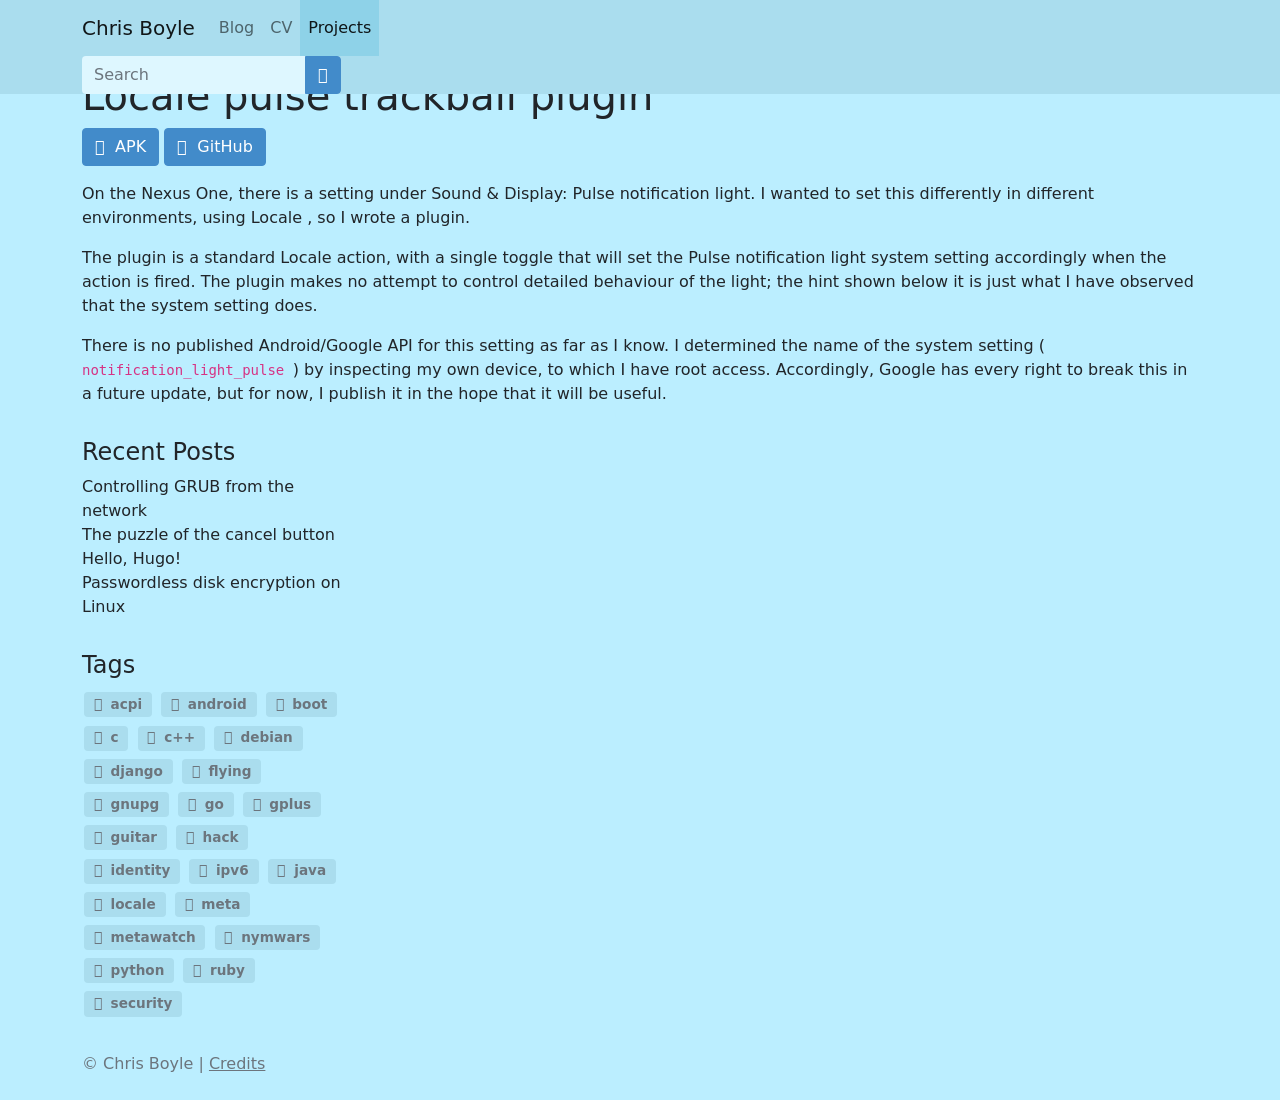What are the challenges of creating such plugins for Android devices? Creating plugins like the 'Locale pulse trackball plugin' for Android devices comes with several challenges. Firstly, developers often have to rely on undocumented features or APIs which might change with new Android versions, risking compatibility issues. Secondly, accessing system settings programmatically can require elevated permissions which could pose security risks or prevent the app from being allowed on the Google Play Store. Finally, maintaining the plugin across different devices and manufacturers is challenging due to the fragmented nature of Android, where different devices might have different capabilities and settings. 